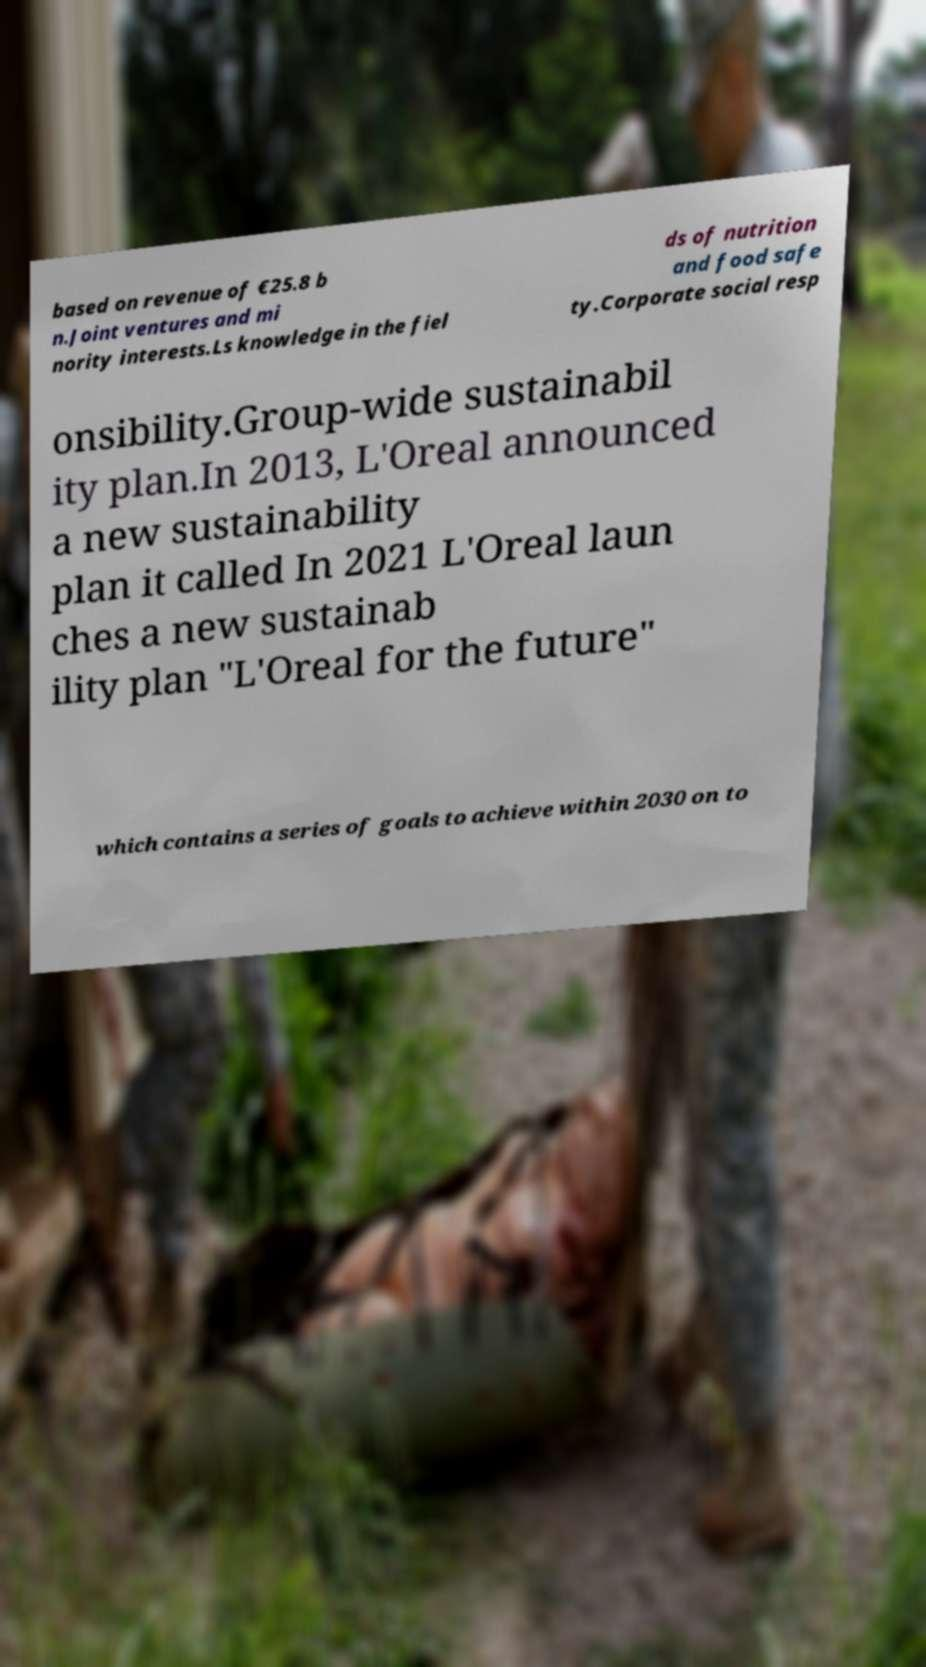Can you read and provide the text displayed in the image?This photo seems to have some interesting text. Can you extract and type it out for me? based on revenue of €25.8 b n.Joint ventures and mi nority interests.Ls knowledge in the fiel ds of nutrition and food safe ty.Corporate social resp onsibility.Group-wide sustainabil ity plan.In 2013, L'Oreal announced a new sustainability plan it called In 2021 L'Oreal laun ches a new sustainab ility plan "L'Oreal for the future" which contains a series of goals to achieve within 2030 on to 